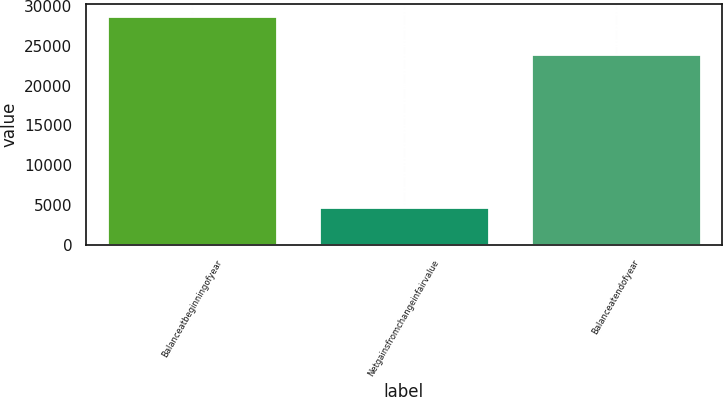Convert chart. <chart><loc_0><loc_0><loc_500><loc_500><bar_chart><fcel>Balanceatbeginningofyear<fcel>Netgainsfromchangeinfairvalue<fcel>Balanceatendofyear<nl><fcel>28770<fcel>4790<fcel>23980<nl></chart> 